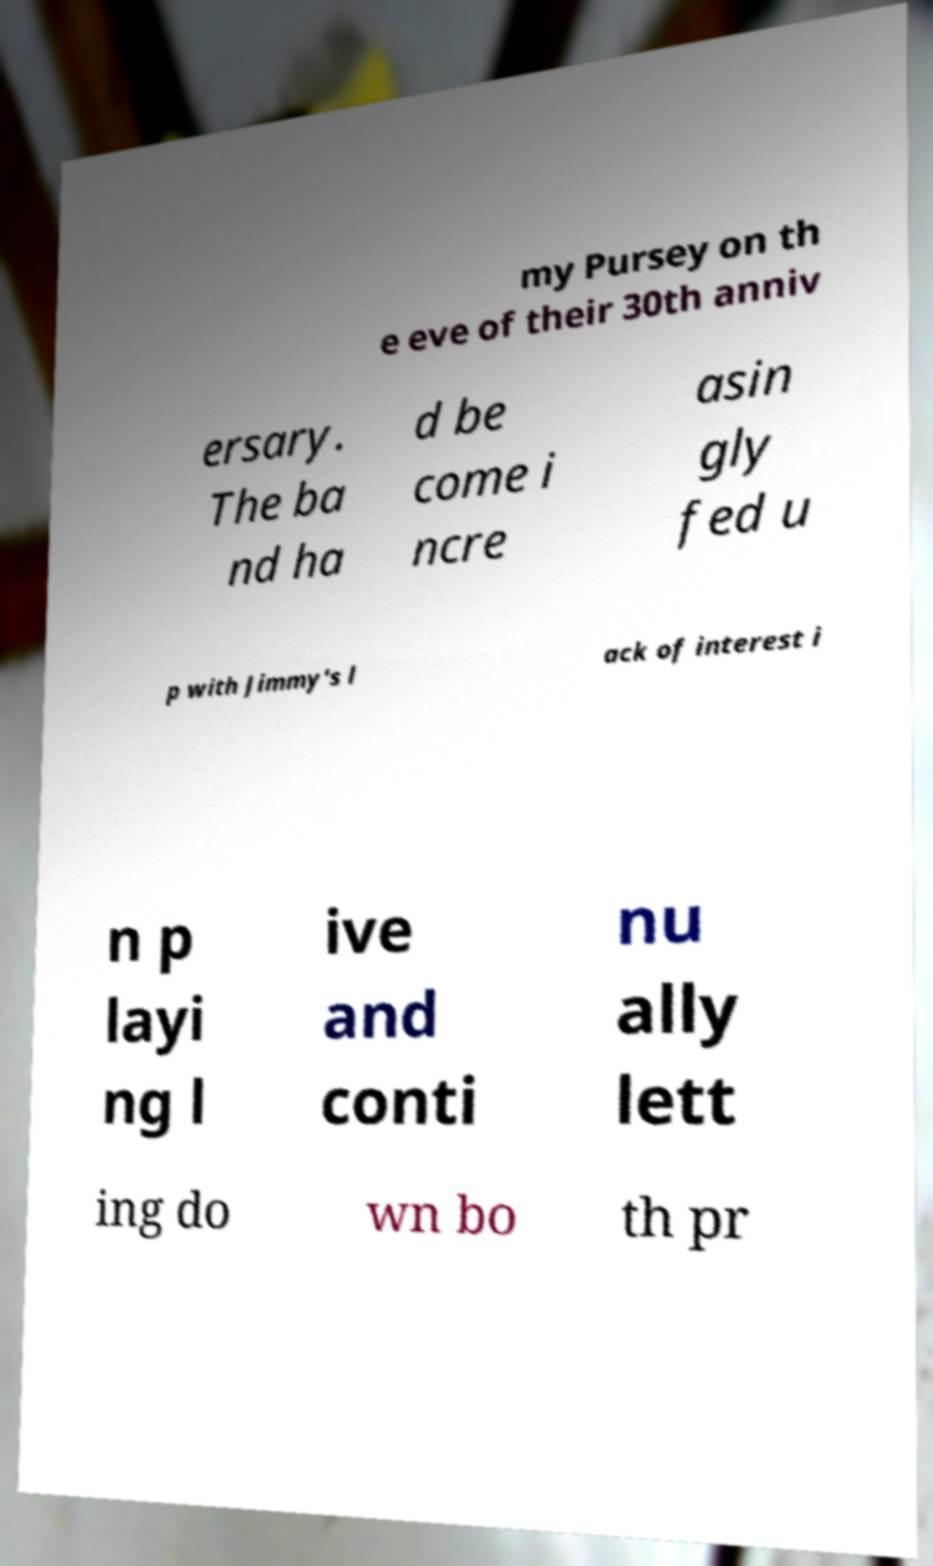What messages or text are displayed in this image? I need them in a readable, typed format. my Pursey on th e eve of their 30th anniv ersary. The ba nd ha d be come i ncre asin gly fed u p with Jimmy's l ack of interest i n p layi ng l ive and conti nu ally lett ing do wn bo th pr 